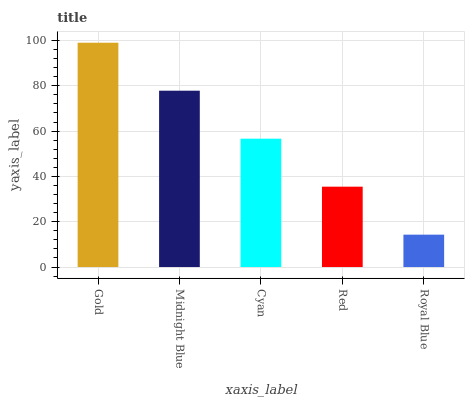Is Midnight Blue the minimum?
Answer yes or no. No. Is Midnight Blue the maximum?
Answer yes or no. No. Is Gold greater than Midnight Blue?
Answer yes or no. Yes. Is Midnight Blue less than Gold?
Answer yes or no. Yes. Is Midnight Blue greater than Gold?
Answer yes or no. No. Is Gold less than Midnight Blue?
Answer yes or no. No. Is Cyan the high median?
Answer yes or no. Yes. Is Cyan the low median?
Answer yes or no. Yes. Is Gold the high median?
Answer yes or no. No. Is Red the low median?
Answer yes or no. No. 